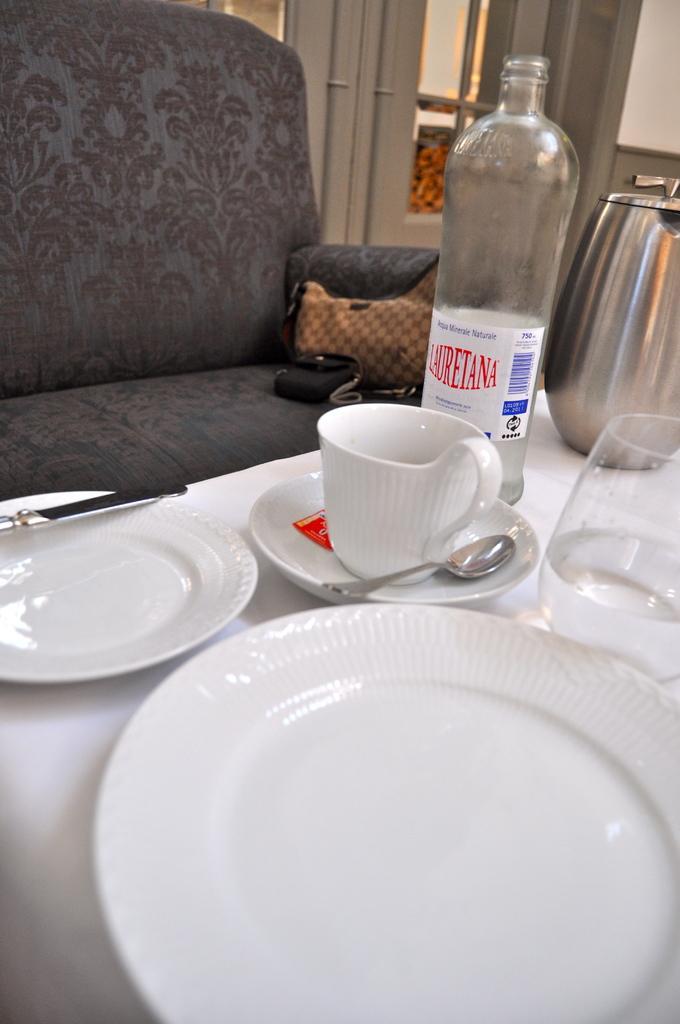In one or two sentences, can you explain what this image depicts? In the picture we can see a table, sofa, on the table we can see few plates, one cup, saucer and spoon, glass, bottle and jar, in the background we can see a window which is white in color with glass frame, on the sofa we can see a black color bag. 